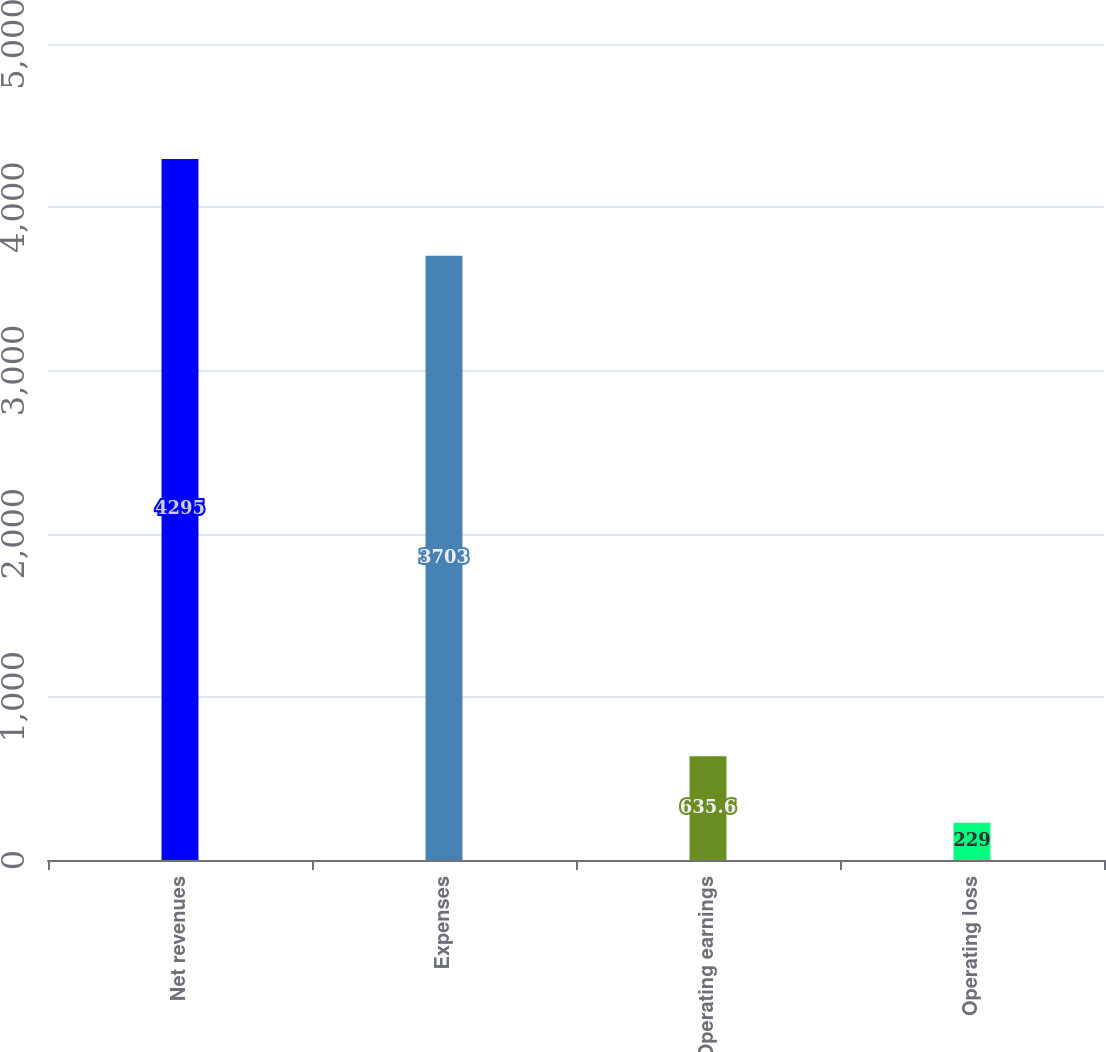<chart> <loc_0><loc_0><loc_500><loc_500><bar_chart><fcel>Net revenues<fcel>Expenses<fcel>Operating earnings<fcel>Operating loss<nl><fcel>4295<fcel>3703<fcel>635.6<fcel>229<nl></chart> 